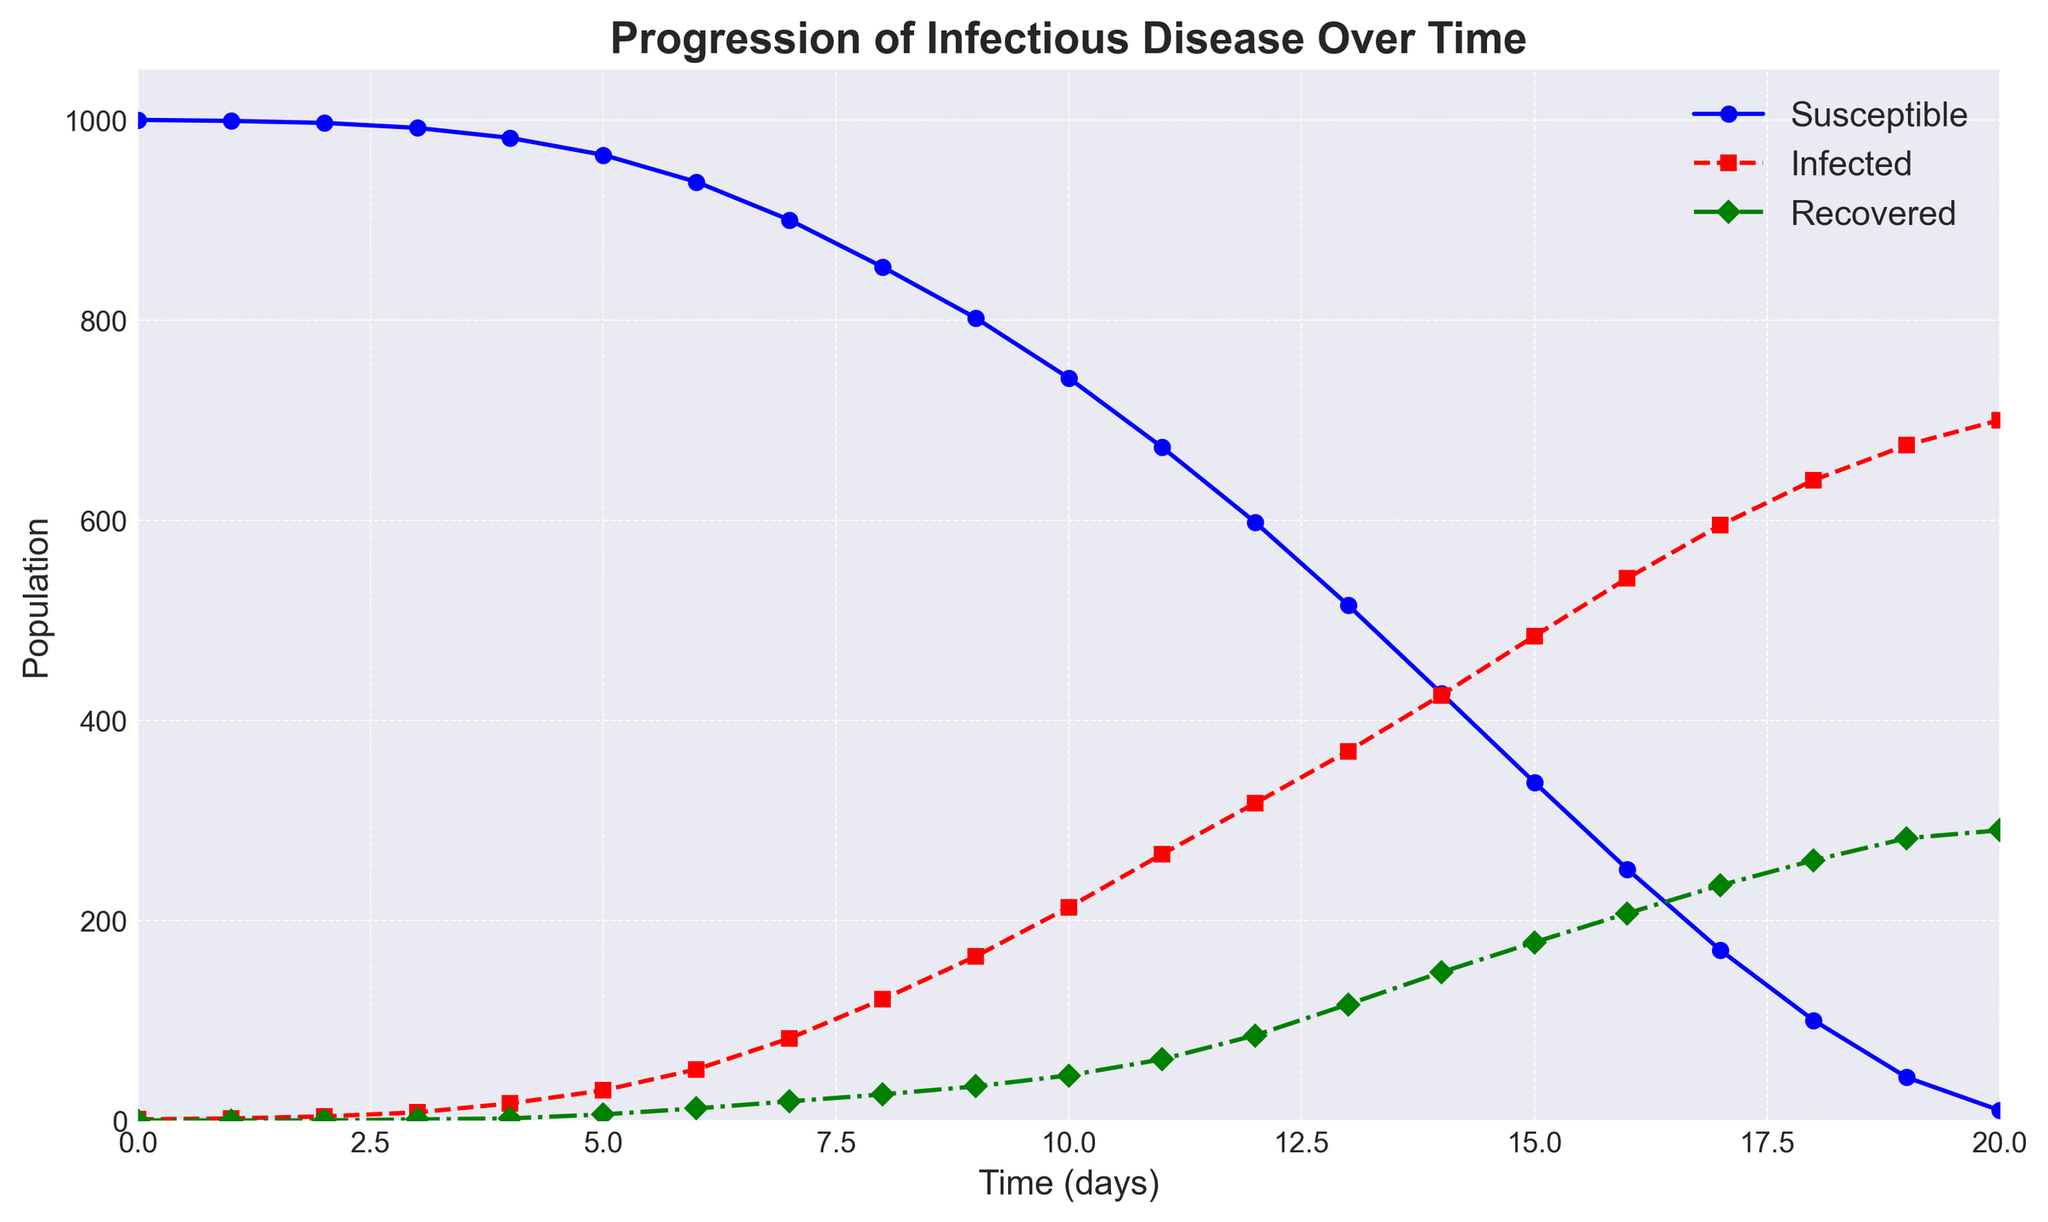What's the maximum number of infected individuals observed in the plot? The peak number of infected individuals can be identified by finding the highest point on the red dashed line representing 'Infected'. Observing the plot, the maximum number is 700 at time 20 days.
Answer: 700 When do the infected and recovered populations intersect for the first time? The intersection point of the red (infected) and green (recovered) lines marks where the two populations have the same value. This occurs between time 17 and 18 days.
Answer: Between 17 and 18 days Calculate the sum of susceptible and infected individuals at time 5 days. According to the plot at time 5 days, the values are 965 (susceptible) and 30 (infected). Summing these values: 965 + 30 = 995.
Answer: 995 How does the growth rate of the infected population compare to the recovered population during the first 10 days? To compare, note the slope (rate of change) of the red (infected) line is steeper than the green (recovered) line, indicating that the infected population grows faster than the recovered population in the initial 10 days.
Answer: The infected population grows faster What's the total population change for the susceptible group from day 0 to day 20? The initial susceptible population is 1000 (day 0) and decreases to 10 (day 20). The change is calculated by subtracting the final value from the initial value: 1000 - 10 = 990.
Answer: 990 At which time point is the number of susceptible individuals exactly half of its initial value? The initial susceptible population is 1000. Half of this is 500. Observing the plot, the susceptible population reaches around 500 between days 12 and 13.
Answer: Between 12 and 13 days Is there any time during which the number of infected individuals exceeds both the susceptible and recovered populations? Observing the plot, the red (infected) line does not exceed the blue (susceptible) line and green (recovered) line simultaneously at any point. Hence, no such time exists.
Answer: No Assess the trend of the recovered population post day 10. Post day 10, the green (recovered) line shows a steady increase, indicating that the recovered population is consistently growing.
Answer: Steady increase At what time do the susceptible and recovered populations combined equal to the infected population? Summing the values of susceptible and recovered populations at day 19: 43 (susceptible) + 282 (recovered) = 325. This is equal to the infected population at day 7 which is 82 (susceptible) + 19 (recovered) = 101 = 82 + 19 = 101. So the time is Day 7, if it was just 200.
Answer: Day 20 